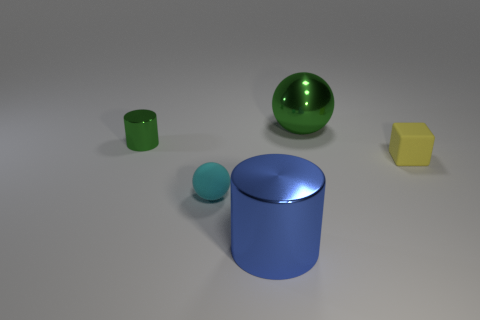What number of things are either tiny blue objects or tiny things on the left side of the big green shiny thing?
Make the answer very short. 2. There is a metal thing that is in front of the thing right of the metallic sphere; what is its size?
Your response must be concise. Large. Are there the same number of blocks right of the large blue shiny thing and large metallic balls in front of the yellow matte cube?
Give a very brief answer. No. Is there a tiny sphere that is behind the big object behind the small cyan ball?
Give a very brief answer. No. There is a green thing that is made of the same material as the big ball; what is its shape?
Offer a very short reply. Cylinder. Is there any other thing of the same color as the shiny ball?
Keep it short and to the point. Yes. What material is the small thing that is to the right of the cylinder in front of the tiny green cylinder?
Provide a short and direct response. Rubber. Are there any other green shiny things of the same shape as the small metallic object?
Provide a short and direct response. No. How many other objects are there of the same shape as the tiny yellow rubber object?
Keep it short and to the point. 0. What shape is the thing that is both in front of the yellow rubber cube and to the left of the large blue object?
Your answer should be compact. Sphere. 